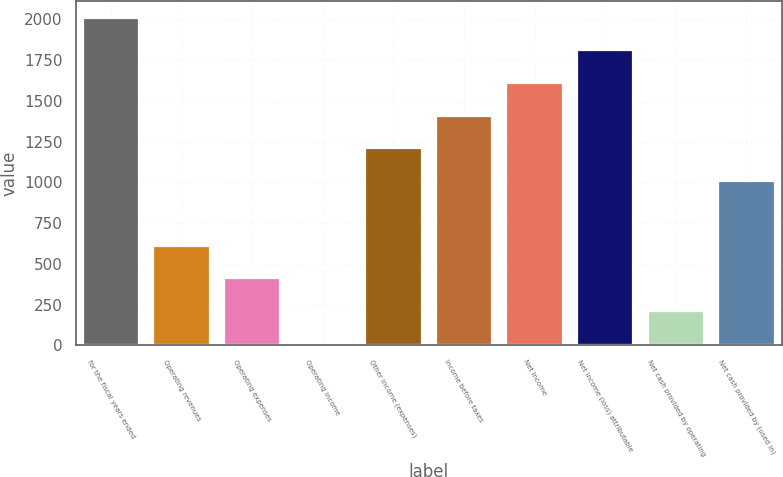<chart> <loc_0><loc_0><loc_500><loc_500><bar_chart><fcel>for the fiscal years ended<fcel>Operating revenues<fcel>Operating expenses<fcel>Operating income<fcel>Other income (expenses)<fcel>Income before taxes<fcel>Net income<fcel>Net income (loss) attributable<fcel>Net cash provided by operating<fcel>Net cash provided by (used in)<nl><fcel>2010<fcel>610.56<fcel>410.64<fcel>10.8<fcel>1210.32<fcel>1410.24<fcel>1610.16<fcel>1810.08<fcel>210.72<fcel>1010.4<nl></chart> 